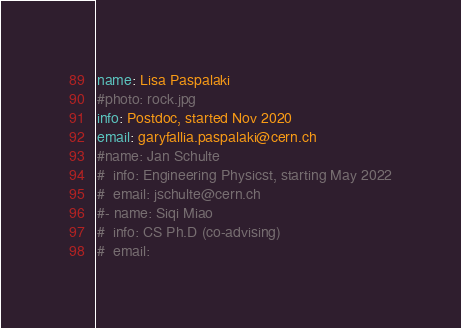<code> <loc_0><loc_0><loc_500><loc_500><_YAML_>name: Lisa Paspalaki
#photo: rock.jpg
info: Postdoc, started Nov 2020
email: garyfallia.paspalaki@cern.ch
#name: Jan Schulte
#  info: Engineering Physicst, starting May 2022
#  email: jschulte@cern.ch
#- name: Siqi Miao
#  info: CS Ph.D (co-advising)
#  email: 
</code> 